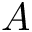Convert formula to latex. <formula><loc_0><loc_0><loc_500><loc_500>A</formula> 